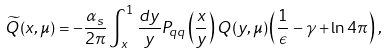<formula> <loc_0><loc_0><loc_500><loc_500>\widetilde { Q } ( x , \mu ) = - \frac { \alpha _ { s } } { 2 \pi } \int _ { x } ^ { 1 } \frac { d y } { y } P _ { q q } \left ( \frac { x } { y } \right ) Q ( y , \mu ) \left ( \frac { 1 } { \epsilon } - \gamma + \ln 4 \pi \right ) \, ,</formula> 